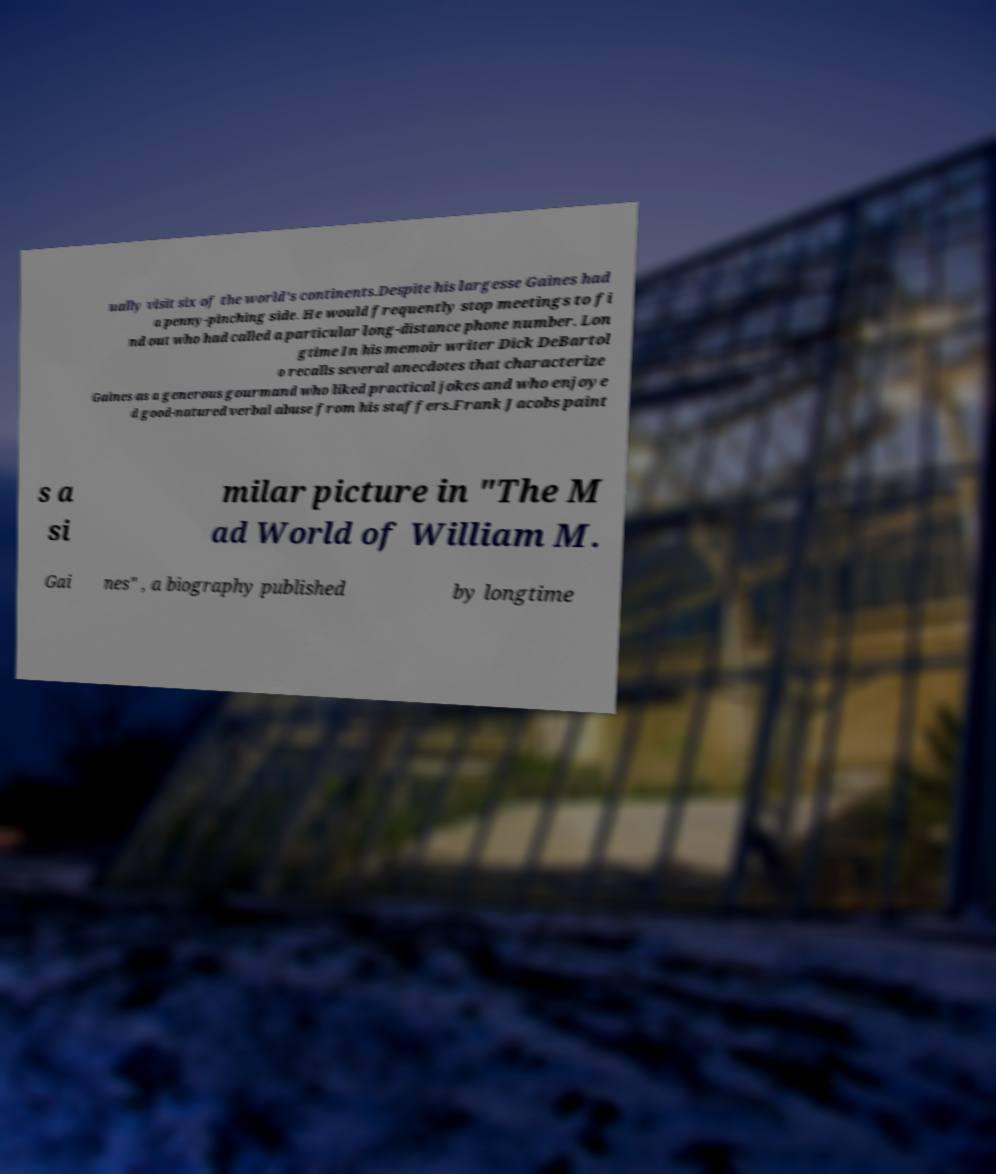Please read and relay the text visible in this image. What does it say? ually visit six of the world's continents.Despite his largesse Gaines had a penny-pinching side. He would frequently stop meetings to fi nd out who had called a particular long-distance phone number. Lon gtime In his memoir writer Dick DeBartol o recalls several anecdotes that characterize Gaines as a generous gourmand who liked practical jokes and who enjoye d good-natured verbal abuse from his staffers.Frank Jacobs paint s a si milar picture in "The M ad World of William M. Gai nes" , a biography published by longtime 